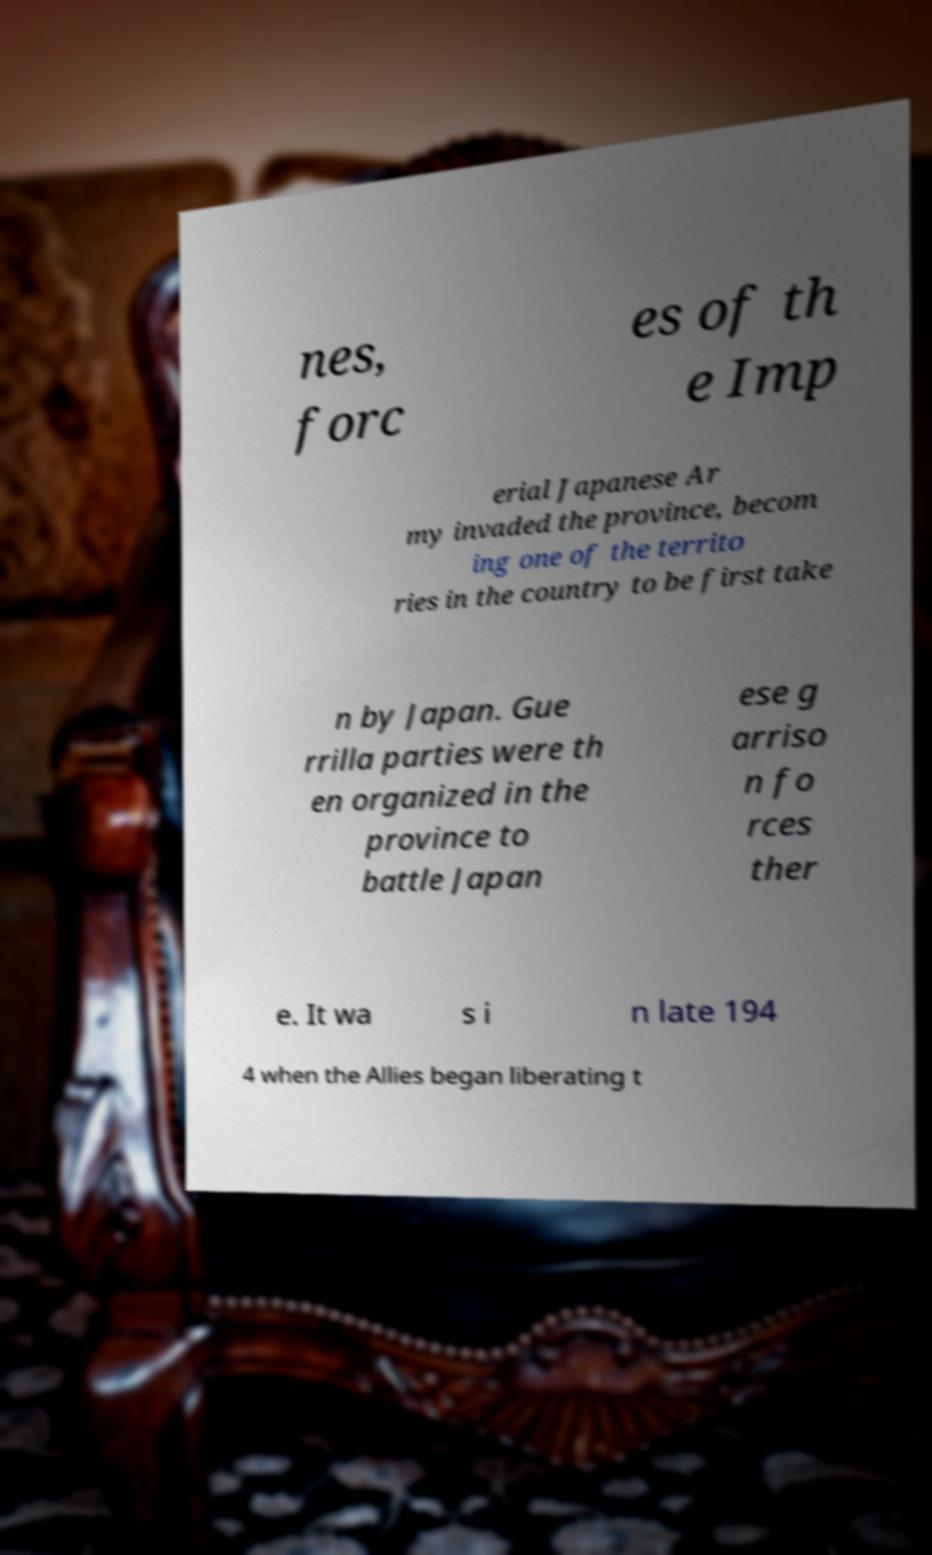Could you extract and type out the text from this image? nes, forc es of th e Imp erial Japanese Ar my invaded the province, becom ing one of the territo ries in the country to be first take n by Japan. Gue rrilla parties were th en organized in the province to battle Japan ese g arriso n fo rces ther e. It wa s i n late 194 4 when the Allies began liberating t 